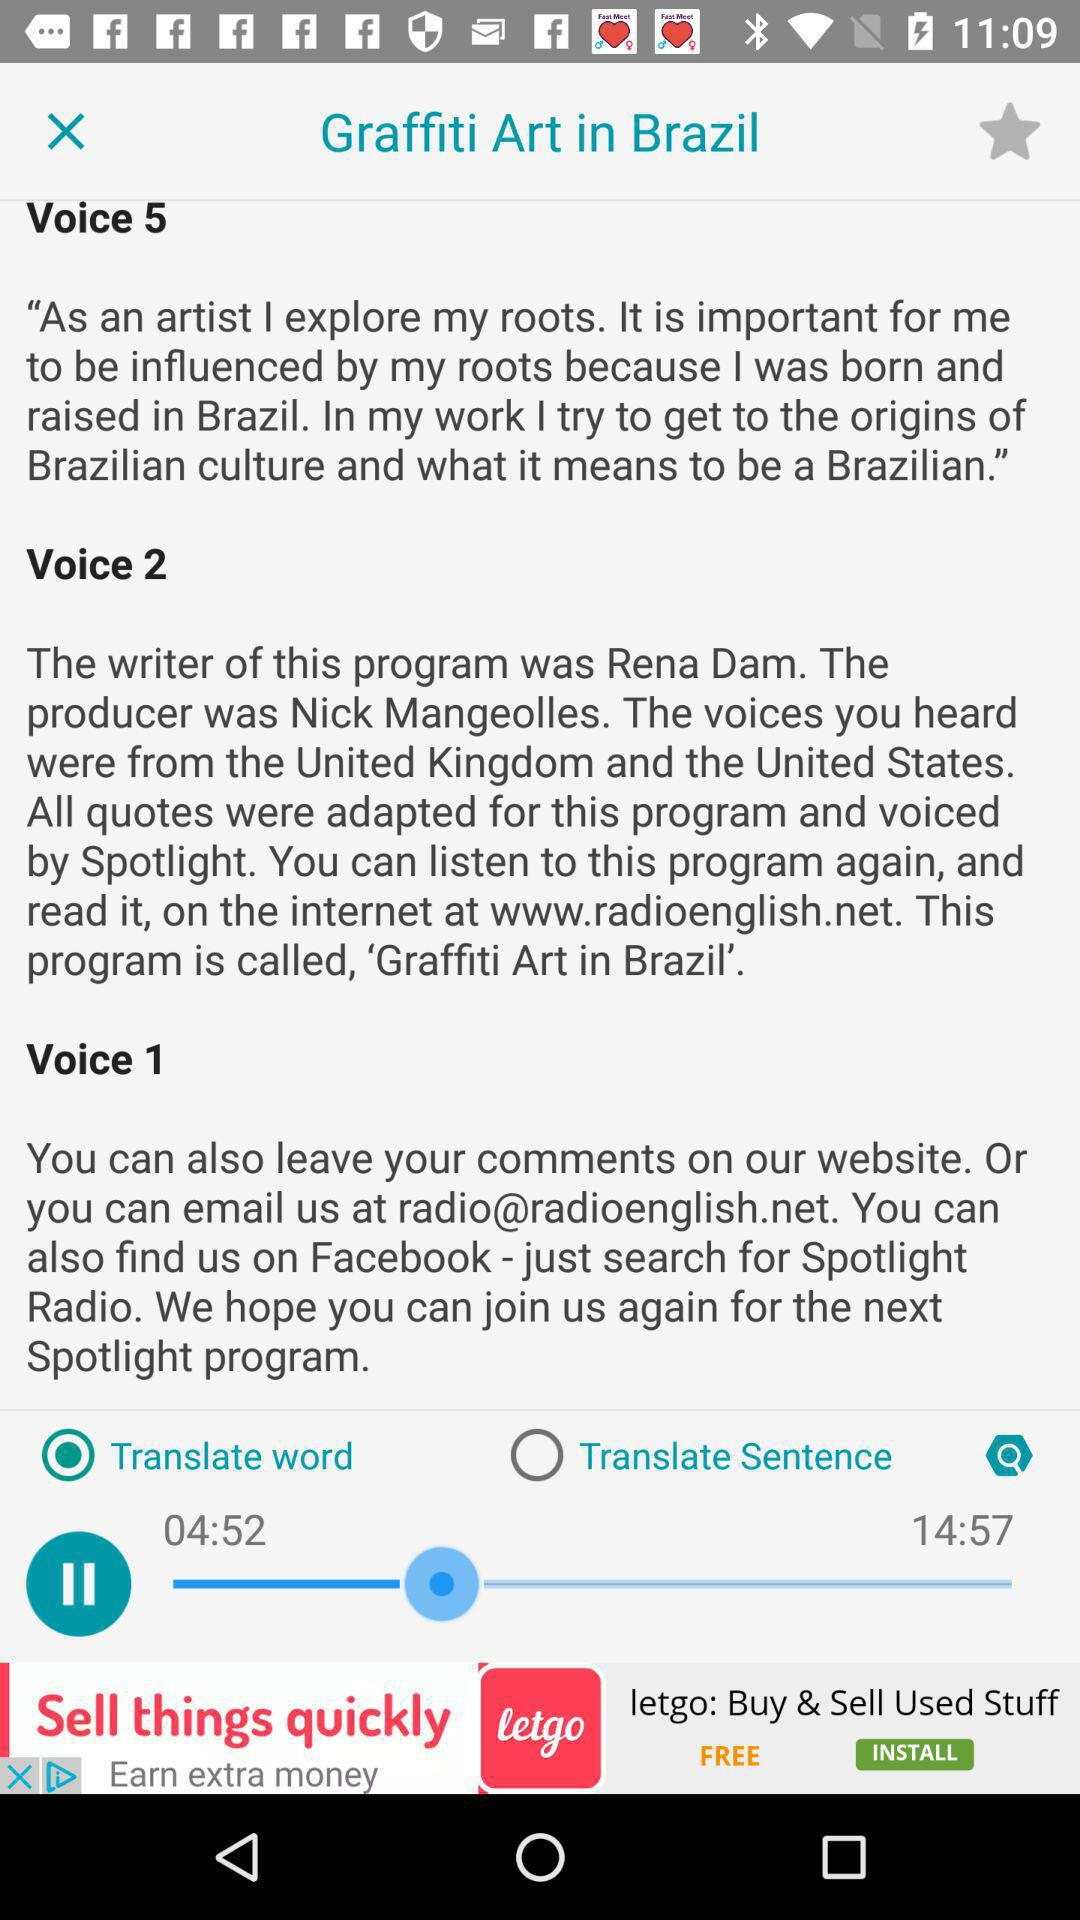How much audio has been played? The audio is played till 4:52. 